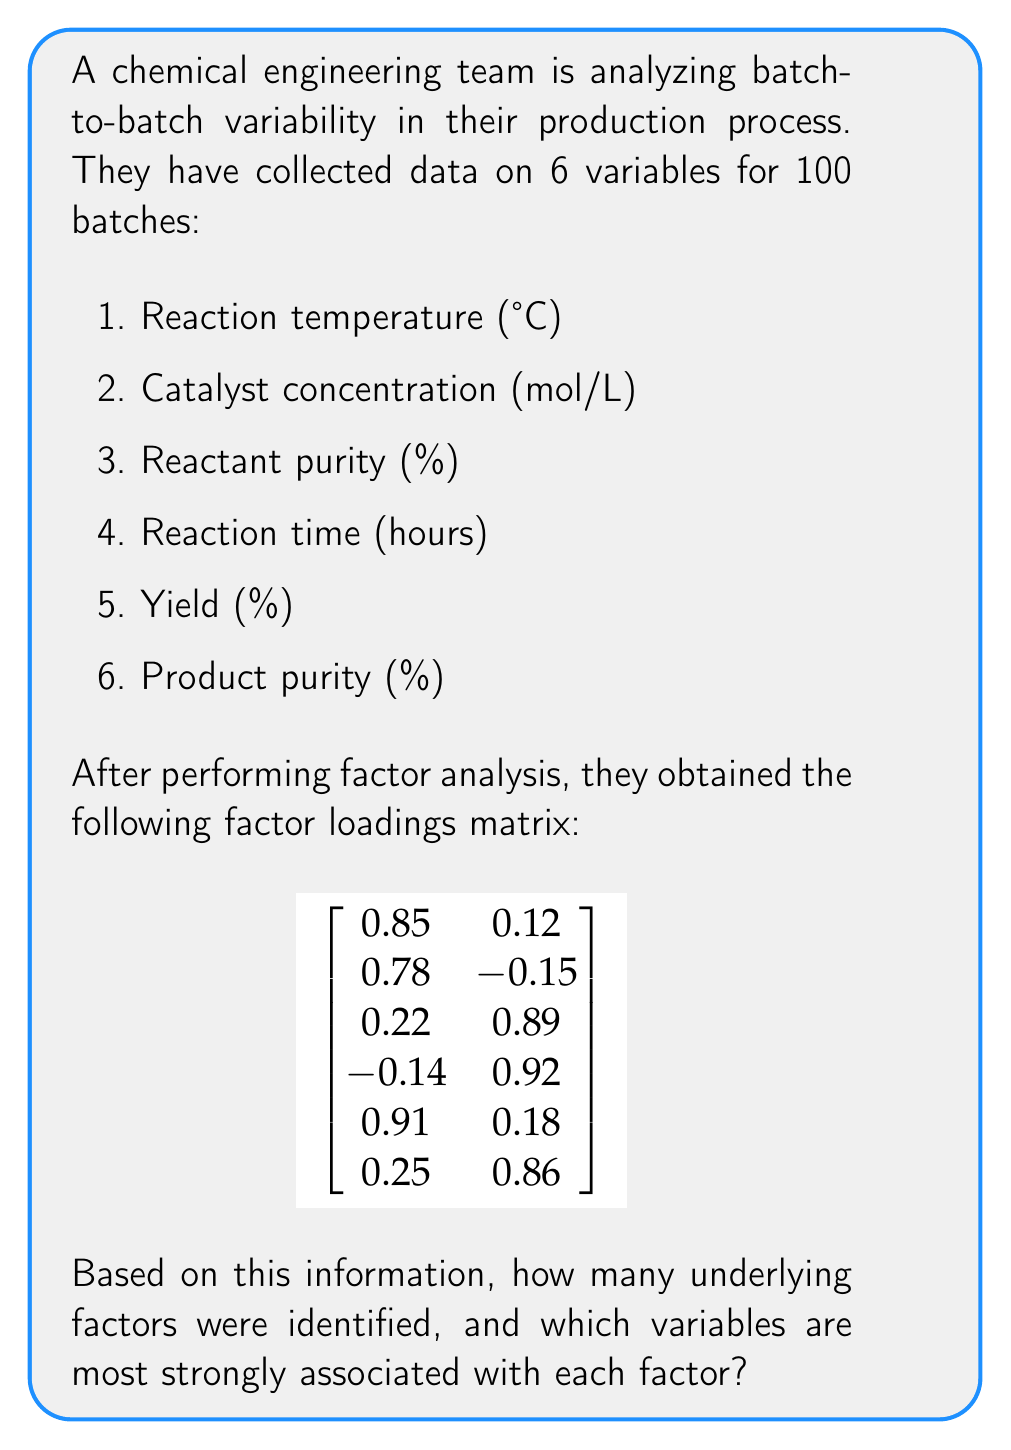Teach me how to tackle this problem. To answer this question, we need to analyze the factor loadings matrix:

1. Identify the number of factors:
   The factor loadings matrix has 2 columns, indicating that 2 underlying factors were identified.

2. Interpret the factor loadings:
   Factor loadings represent the correlation between each variable and the underlying factor. Generally, loadings above 0.7 are considered strong.

3. Analyze Factor 1 (first column):
   - Reaction temperature: 0.85 (strong)
   - Catalyst concentration: 0.78 (strong)
   - Yield: 0.91 (strong)
   Other variables have weak loadings for this factor.

4. Analyze Factor 2 (second column):
   - Reactant purity: 0.89 (strong)
   - Reaction time: 0.92 (strong)
   - Product purity: 0.86 (strong)
   Other variables have weak loadings for this factor.

5. Interpret the results:
   Factor 1 is strongly associated with reaction temperature, catalyst concentration, and yield. This factor could represent the "Reaction Efficiency" aspect of the process.
   
   Factor 2 is strongly associated with reactant purity, reaction time, and product purity. This factor could represent the "Product Quality" aspect of the process.

These two underlying factors explain the majority of the batch-to-batch variability in the chemical production process.
Answer: 2 factors: Factor 1 (Reaction Efficiency) associated with temperature, catalyst concentration, and yield; Factor 2 (Product Quality) associated with reactant purity, reaction time, and product purity. 